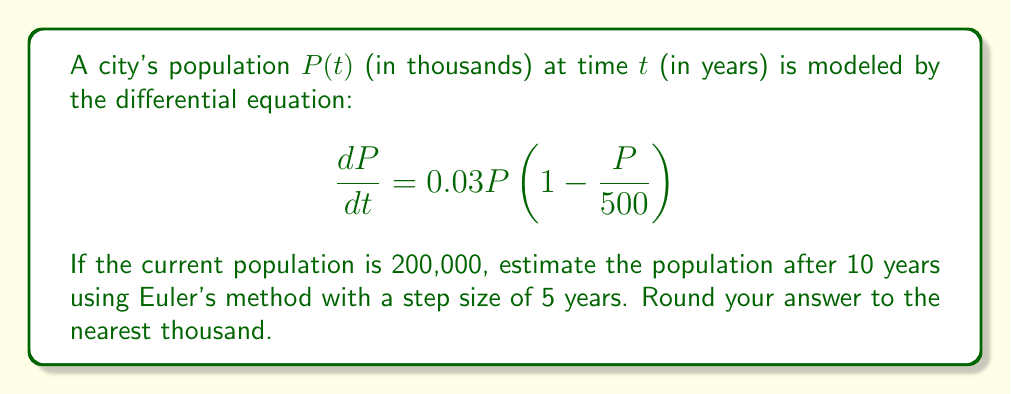What is the answer to this math problem? Let's approach this step-by-step using Euler's method:

1) Euler's method is given by the formula:
   $P_{n+1} = P_n + h \cdot f(t_n, P_n)$
   where $h$ is the step size and $f(t, P) = \frac{dP}{dt}$

2) In this case:
   $f(t, P) = 0.03P(1 - \frac{P}{500})$
   $h = 5$ years
   Initial $P_0 = 200$ (in thousands)

3) We need to perform two steps to reach 10 years:

   Step 1 (0 to 5 years):
   $P_1 = P_0 + h \cdot f(t_0, P_0)$
   $= 200 + 5 \cdot 0.03 \cdot 200(1 - \frac{200}{500})$
   $= 200 + 5 \cdot 0.03 \cdot 200 \cdot 0.6$
   $= 200 + 18 = 218$

   Step 2 (5 to 10 years):
   $P_2 = P_1 + h \cdot f(t_1, P_1)$
   $= 218 + 5 \cdot 0.03 \cdot 218(1 - \frac{218}{500})$
   $= 218 + 5 \cdot 0.03 \cdot 218 \cdot 0.564$
   $= 218 + 18.4572 = 236.4572$

4) Rounding to the nearest thousand:
   236,457 ≈ 236,000
Answer: 236,000 